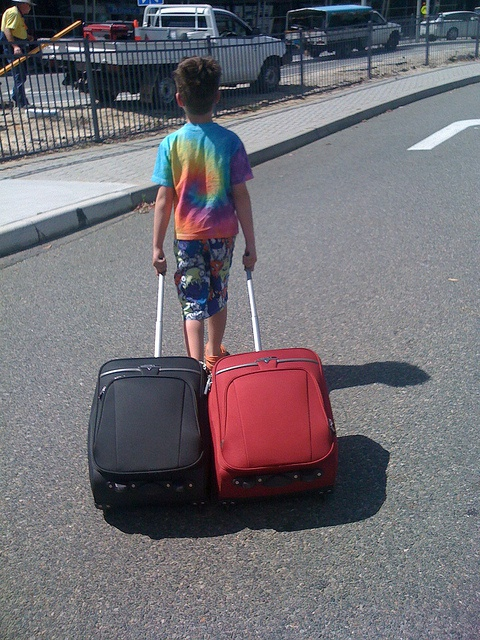Describe the objects in this image and their specific colors. I can see people in black, gray, navy, and purple tones, suitcase in black and brown tones, suitcase in black and gray tones, truck in black, gray, and navy tones, and truck in black, navy, gray, and blue tones in this image. 